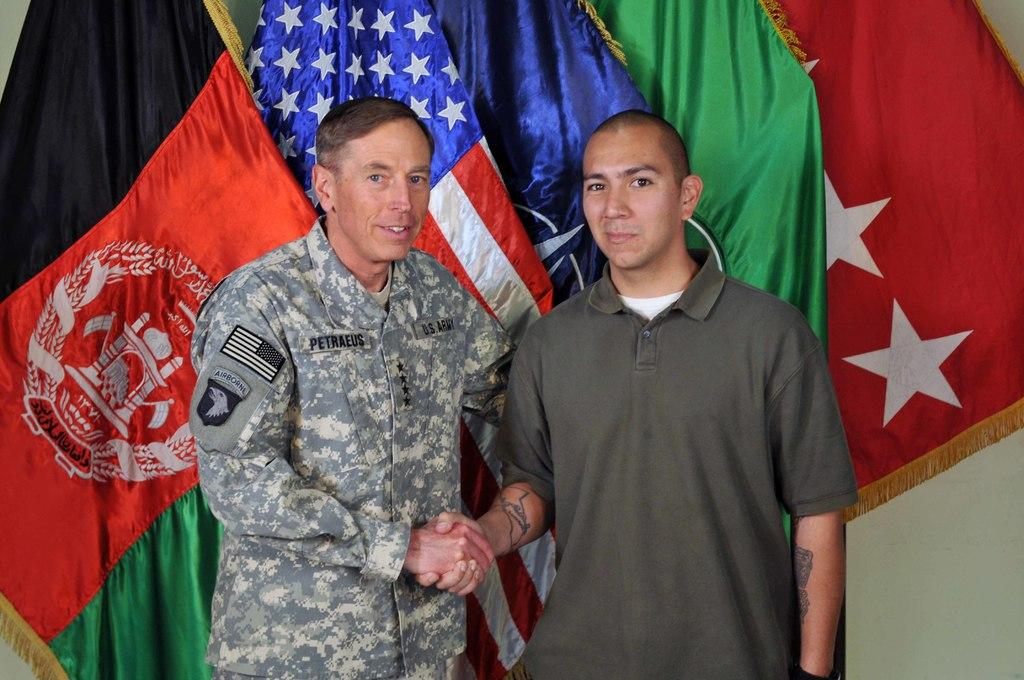<image>
Create a compact narrative representing the image presented. Man with a uniform that says "petraeus" shaking hands with another man. 